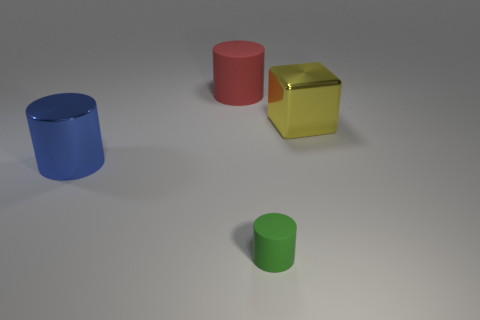Are there any large red matte objects in front of the blue metal cylinder?
Provide a succinct answer. No. What number of big purple things are the same shape as the large red rubber object?
Provide a short and direct response. 0. Do the green cylinder and the yellow object on the right side of the small green cylinder have the same material?
Your answer should be very brief. No. How many big red things are there?
Your response must be concise. 1. There is a thing that is on the left side of the red matte cylinder; how big is it?
Give a very brief answer. Large. What number of red rubber cylinders are the same size as the blue metallic object?
Ensure brevity in your answer.  1. What material is the cylinder that is behind the small thing and to the right of the blue cylinder?
Your answer should be compact. Rubber. What material is the blue cylinder that is the same size as the yellow metal cube?
Your answer should be compact. Metal. What is the size of the cylinder that is behind the big metallic object that is on the right side of the rubber cylinder behind the green rubber cylinder?
Keep it short and to the point. Large. There is a green cylinder that is made of the same material as the red cylinder; what size is it?
Ensure brevity in your answer.  Small. 